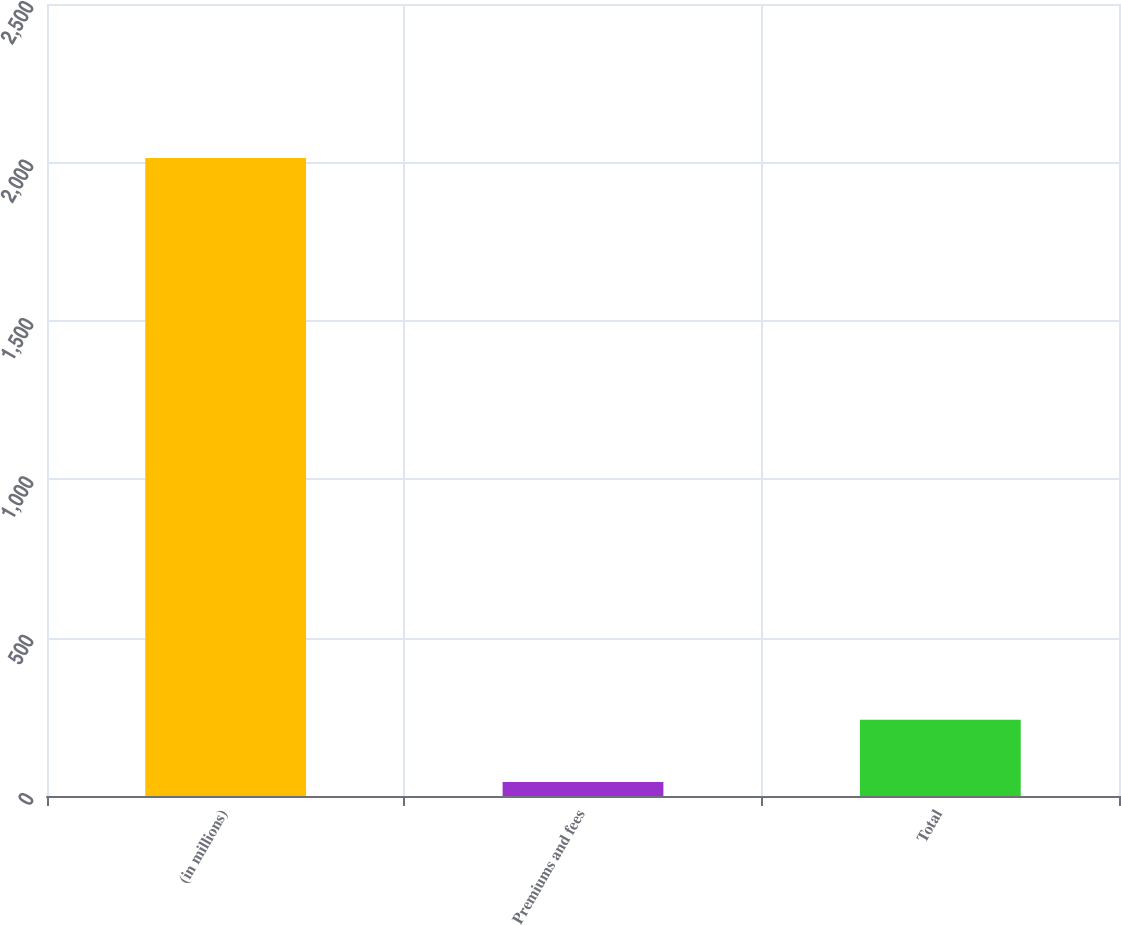<chart> <loc_0><loc_0><loc_500><loc_500><bar_chart><fcel>(in millions)<fcel>Premiums and fees<fcel>Total<nl><fcel>2014<fcel>44<fcel>241<nl></chart> 